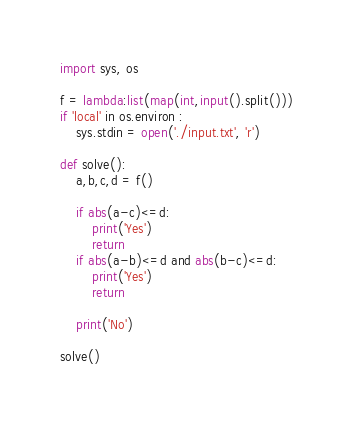<code> <loc_0><loc_0><loc_500><loc_500><_Python_>import sys, os

f = lambda:list(map(int,input().split()))
if 'local' in os.environ :
    sys.stdin = open('./input.txt', 'r')

def solve():
    a,b,c,d = f()

    if abs(a-c)<=d:
        print('Yes')
        return
    if abs(a-b)<=d and abs(b-c)<=d:
        print('Yes')
        return
    
    print('No')

solve()
</code> 